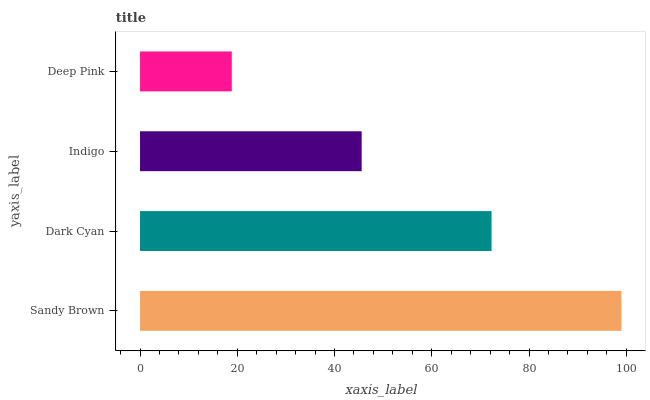Is Deep Pink the minimum?
Answer yes or no. Yes. Is Sandy Brown the maximum?
Answer yes or no. Yes. Is Dark Cyan the minimum?
Answer yes or no. No. Is Dark Cyan the maximum?
Answer yes or no. No. Is Sandy Brown greater than Dark Cyan?
Answer yes or no. Yes. Is Dark Cyan less than Sandy Brown?
Answer yes or no. Yes. Is Dark Cyan greater than Sandy Brown?
Answer yes or no. No. Is Sandy Brown less than Dark Cyan?
Answer yes or no. No. Is Dark Cyan the high median?
Answer yes or no. Yes. Is Indigo the low median?
Answer yes or no. Yes. Is Indigo the high median?
Answer yes or no. No. Is Dark Cyan the low median?
Answer yes or no. No. 